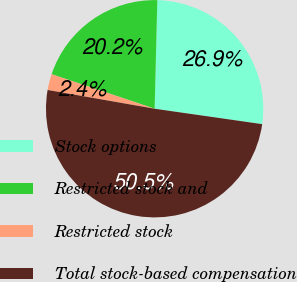Convert chart. <chart><loc_0><loc_0><loc_500><loc_500><pie_chart><fcel>Stock options<fcel>Restricted stock and<fcel>Restricted stock<fcel>Total stock-based compensation<nl><fcel>26.87%<fcel>20.25%<fcel>2.38%<fcel>50.5%<nl></chart> 